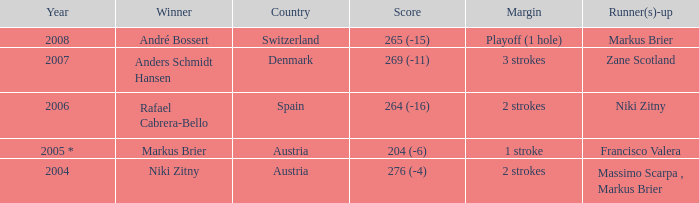What was the country when the margin was 2 strokes, and when the score was 276 (-4)? Austria. 